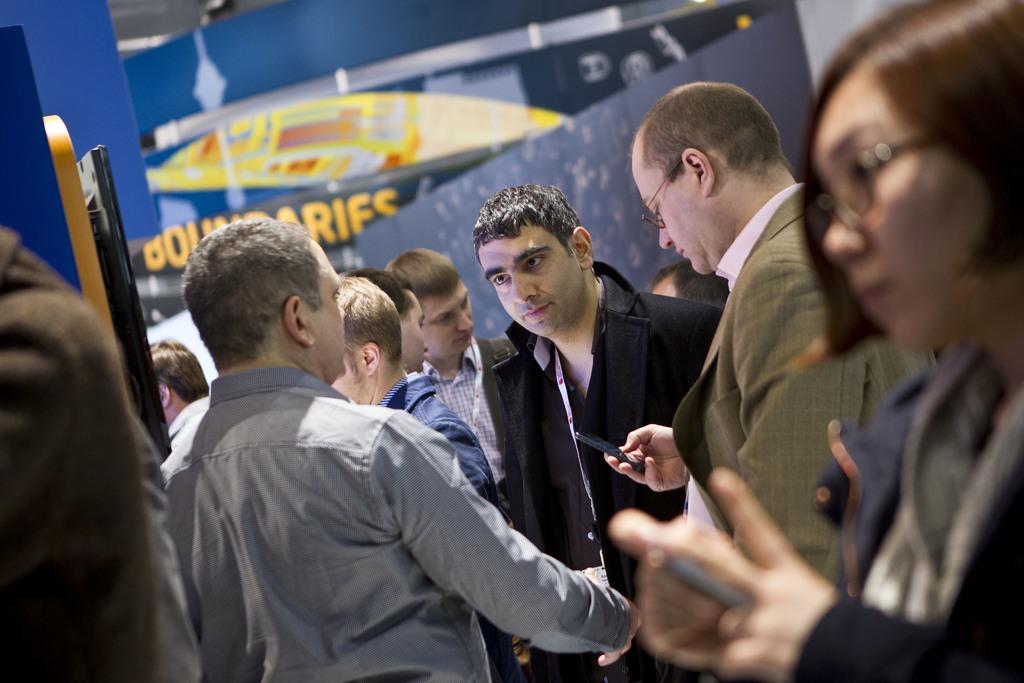Can you describe this image briefly? In the image in the center, we can see a few people are standing and few people are holding some objects. In the background there is wall, banners and a few other objects. 